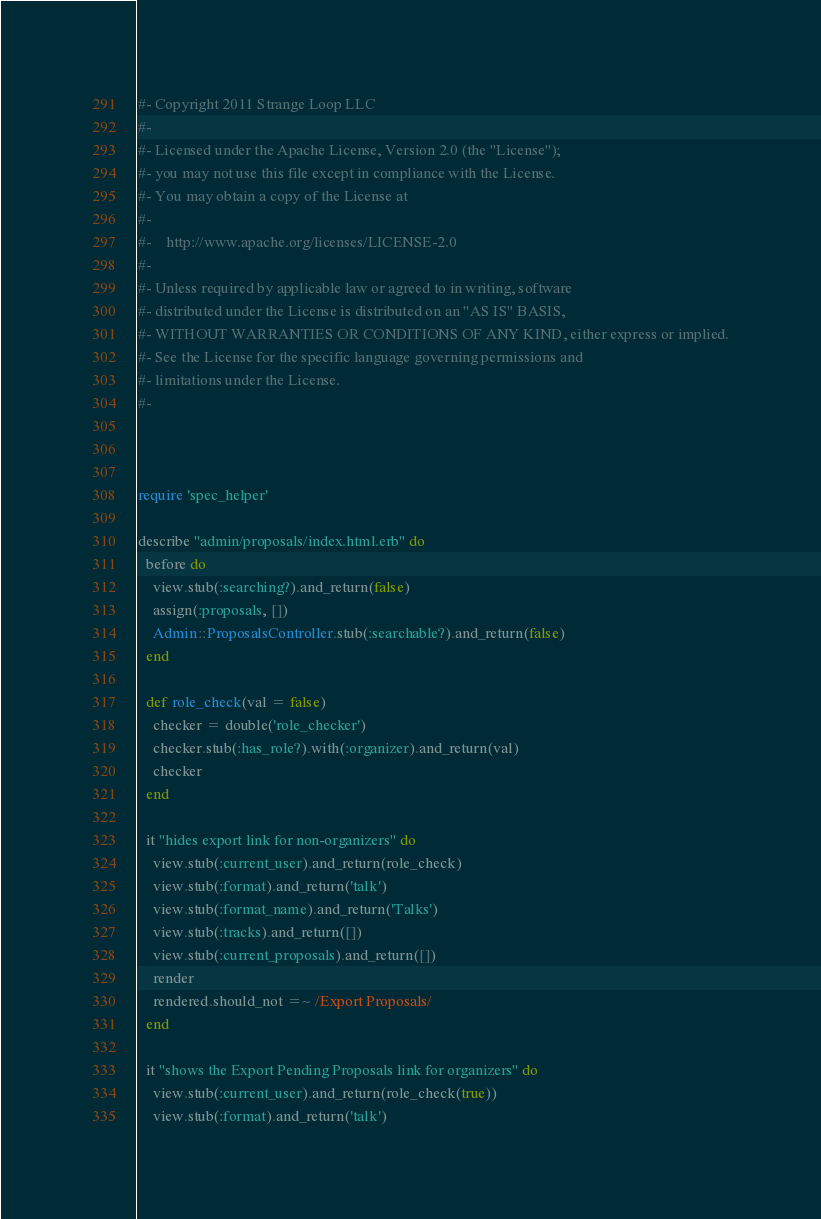Convert code to text. <code><loc_0><loc_0><loc_500><loc_500><_Ruby_>#- Copyright 2011 Strange Loop LLC
#-
#- Licensed under the Apache License, Version 2.0 (the "License");
#- you may not use this file except in compliance with the License.
#- You may obtain a copy of the License at
#-
#-    http://www.apache.org/licenses/LICENSE-2.0
#-
#- Unless required by applicable law or agreed to in writing, software
#- distributed under the License is distributed on an "AS IS" BASIS,
#- WITHOUT WARRANTIES OR CONDITIONS OF ANY KIND, either express or implied.
#- See the License for the specific language governing permissions and
#- limitations under the License.
#-



require 'spec_helper'

describe "admin/proposals/index.html.erb" do
  before do
    view.stub(:searching?).and_return(false)
    assign(:proposals, [])
    Admin::ProposalsController.stub(:searchable?).and_return(false)
  end

  def role_check(val = false)
    checker = double('role_checker')
    checker.stub(:has_role?).with(:organizer).and_return(val)
    checker
  end

  it "hides export link for non-organizers" do
    view.stub(:current_user).and_return(role_check)
    view.stub(:format).and_return('talk')
    view.stub(:format_name).and_return('Talks')
    view.stub(:tracks).and_return([])
    view.stub(:current_proposals).and_return([])
    render
    rendered.should_not =~ /Export Proposals/
  end

  it "shows the Export Pending Proposals link for organizers" do
    view.stub(:current_user).and_return(role_check(true))
    view.stub(:format).and_return('talk')</code> 